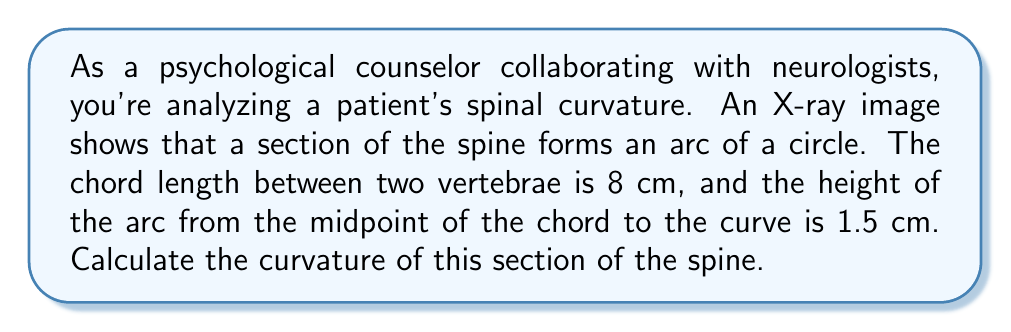Provide a solution to this math problem. To compute the curvature of the spine, we'll use geometric formulas related to circular arcs. The curvature of a circle is the reciprocal of its radius. So, we need to find the radius of the circle that this arc is a part of.

Step 1: Identify the known values
- Chord length (c) = 8 cm
- Height of the arc (h) = 1.5 cm

Step 2: Use the formula for the radius of a circular segment
The formula is: $R = \frac{h}{2} + \frac{c^2}{8h}$
Where R is the radius, h is the height of the arc, and c is the chord length.

Step 3: Substitute the values into the formula
$$R = \frac{1.5}{2} + \frac{8^2}{8(1.5)}$$

Step 4: Calculate
$$R = 0.75 + \frac{64}{12} = 0.75 + 5.33 = 6.08 \text{ cm}$$

Step 5: Calculate the curvature
Curvature (κ) is the reciprocal of the radius:
$$κ = \frac{1}{R} = \frac{1}{6.08} \approx 0.1645 \text{ cm}^{-1}$$

[asy]
import geometry;

pair A = (-4,0), B = (4,0), C = (0,1.5);
path arc = Arc(A,C,B);
draw(A--B,black);
draw(arc,black);
draw((0,0)--C,dashed);
label("8 cm", (0,-0.5));
label("1.5 cm", (0.5,0.75), E);
[/asy]
Answer: $0.1645 \text{ cm}^{-1}$ 